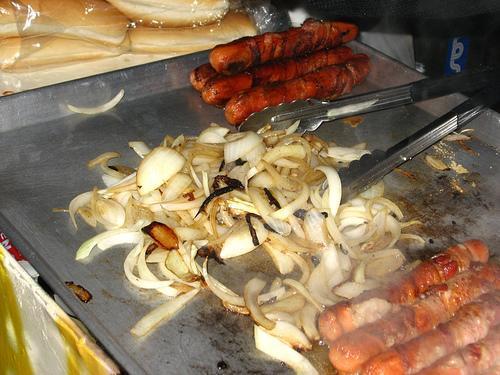How many sausages are being cooked?
Give a very brief answer. 4. How many hot dogs can you see?
Give a very brief answer. 7. 